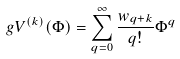<formula> <loc_0><loc_0><loc_500><loc_500>g V ^ { ( k ) } ( \Phi ) = \sum _ { q = 0 } ^ { \infty } \frac { w _ { q + k } } { q ! } \Phi ^ { q }</formula> 